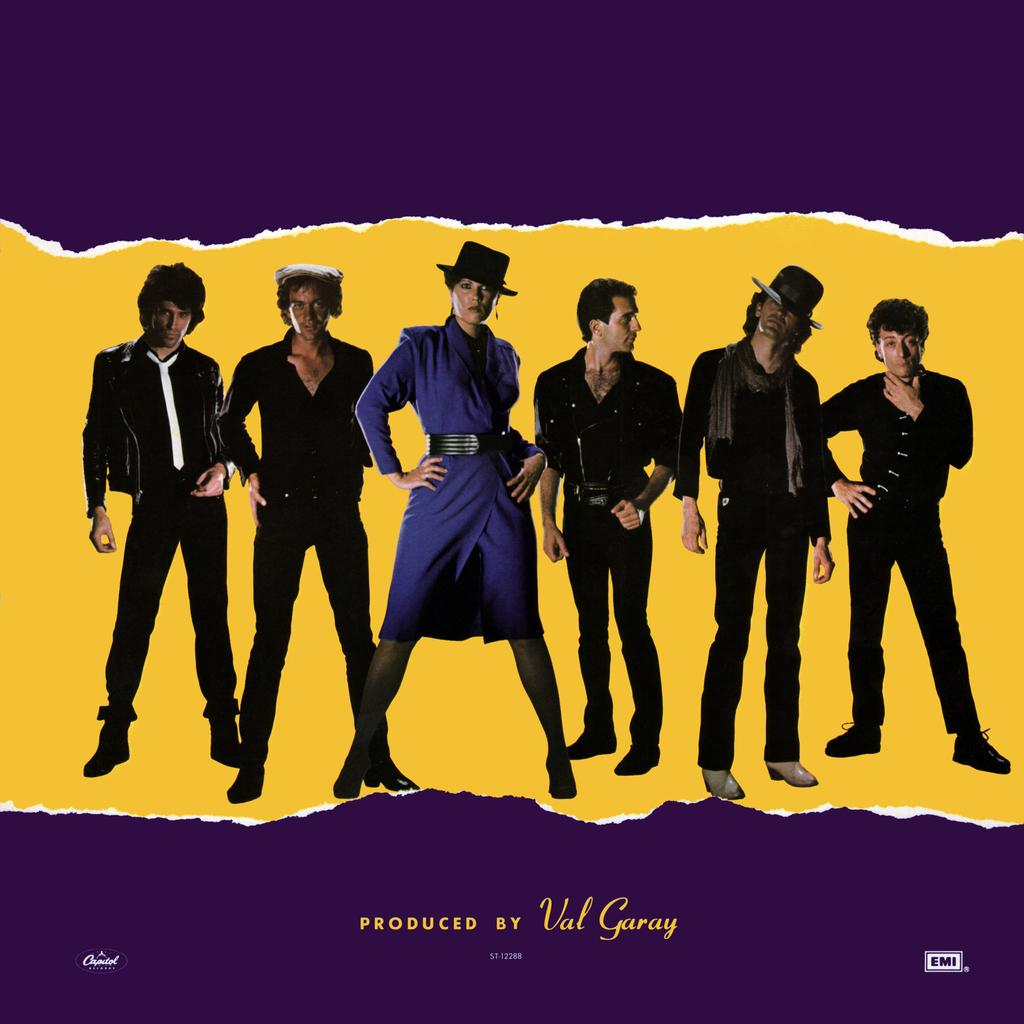What type of visual is the image? The image is a poster. What can be seen in the poster? There are people depicted in the poster. Where is the text located in the poster? The text is at the bottom of the poster. What type of collar is being worn by the people in the poster? There is no collar mentioned or visible in the poster; it only depicts people and text. 